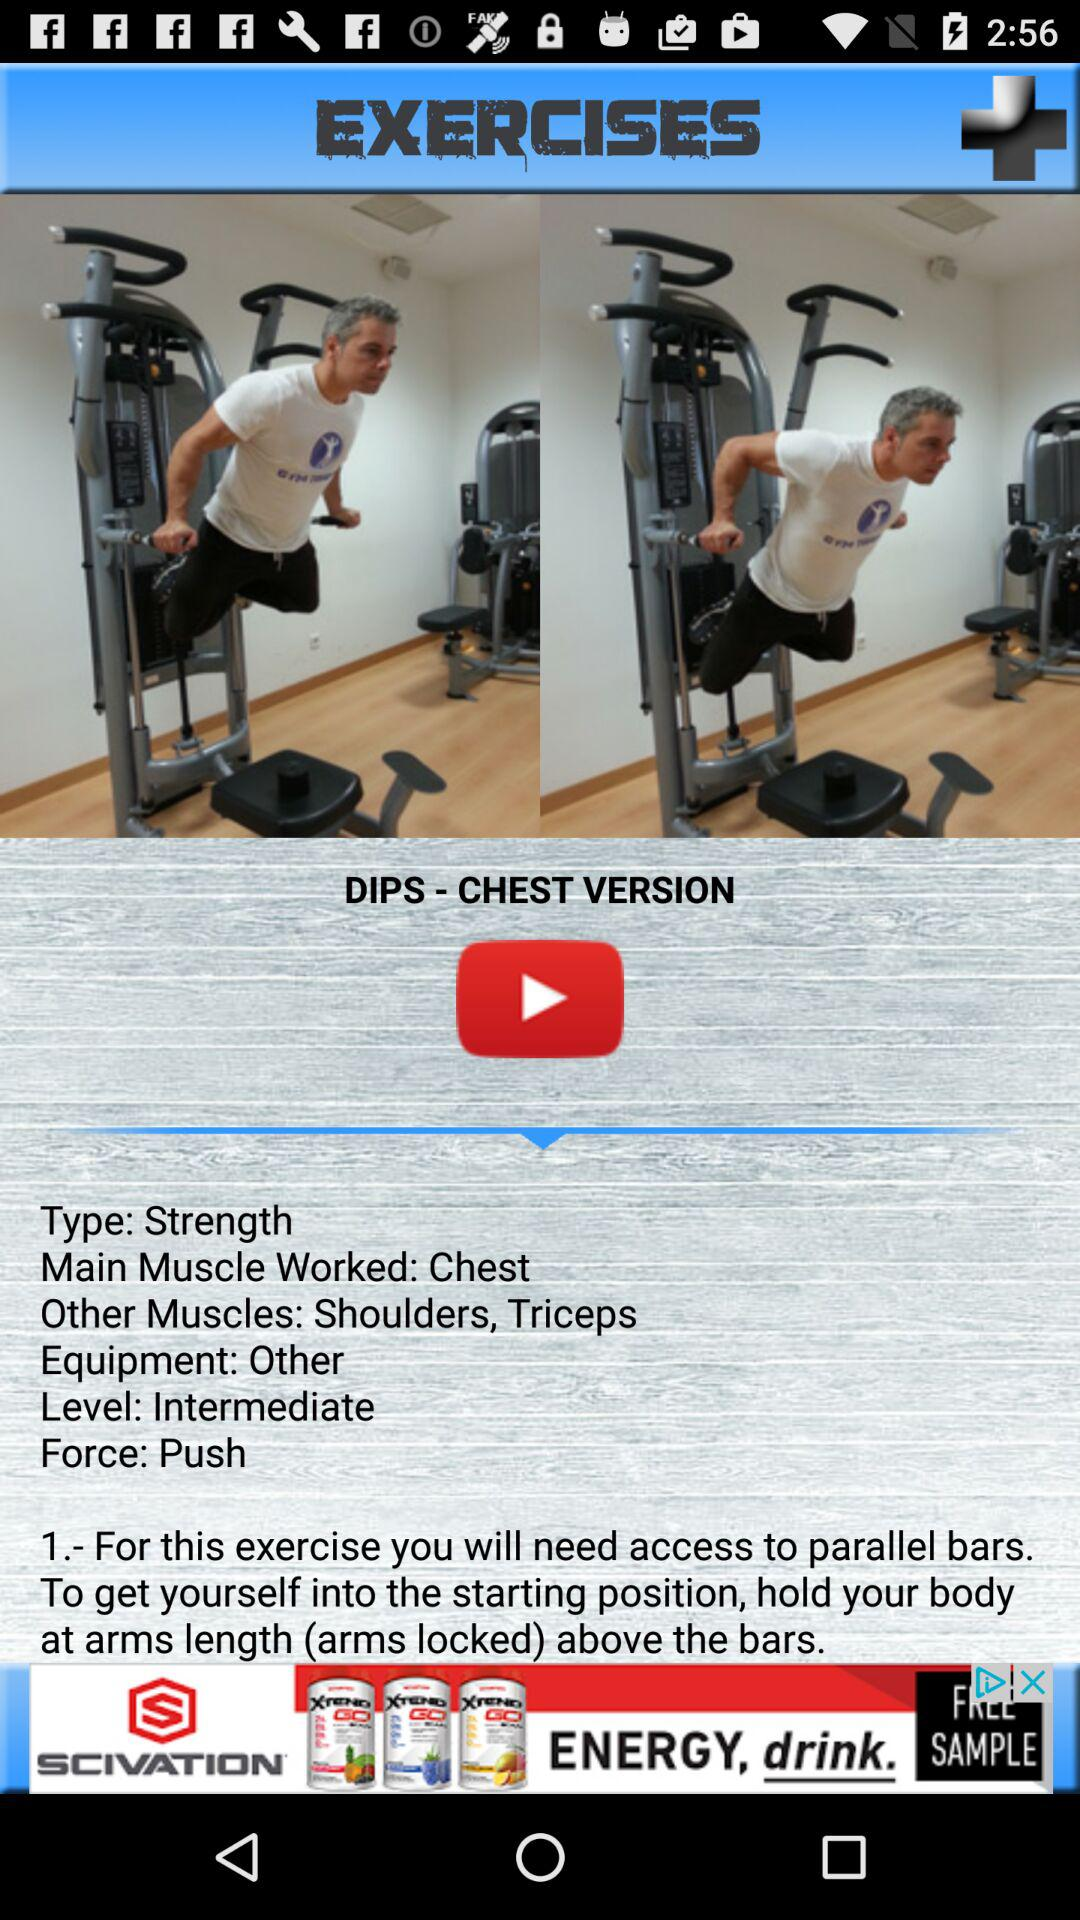What are the other muscles worked in the exercise? The other muscles worked in the exercise are the shoulders and triceps. 